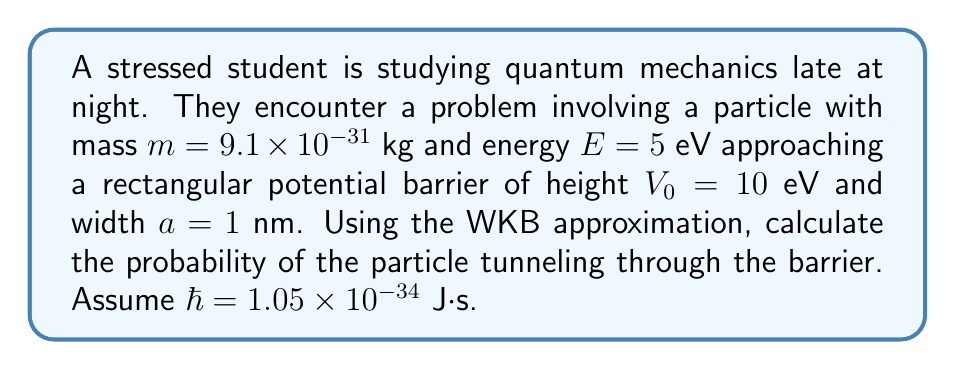Solve this math problem. Let's approach this step-by-step:

1) The WKB approximation for the tunneling probability is given by:

   $$T \approx \exp\left(-\frac{2}{\hbar}\int_0^a \sqrt{2m(V(x)-E)} dx\right)$$

2) For a rectangular barrier, $V(x) = V_0$ (constant), so we can simplify:

   $$T \approx \exp\left(-\frac{2}{\hbar}\sqrt{2m(V_0-E)}a\right)$$

3) Convert energy units from eV to J:
   $E = 5 \text{ eV} = 5 \times 1.6 \times 10^{-19} \text{ J} = 8 \times 10^{-19} \text{ J}$
   $V_0 = 10 \text{ eV} = 1.6 \times 10^{-18} \text{ J}$

4) Substitute the values:
   $$T \approx \exp\left(-\frac{2}{1.05 \times 10^{-34}}\sqrt{2 \times 9.1 \times 10^{-31}(1.6 \times 10^{-18} - 8 \times 10^{-19})} \times 10^{-9}\right)$$

5) Simplify inside the square root:
   $$T \approx \exp\left(-\frac{2}{1.05 \times 10^{-34}}\sqrt{2 \times 9.1 \times 10^{-31} \times 8 \times 10^{-19}} \times 10^{-9}\right)$$

6) Calculate:
   $$T \approx \exp(-4.83) \approx 0.008$$

7) Convert to percentage:
   $$T \approx 0.8\%$$
Answer: $0.8\%$ 